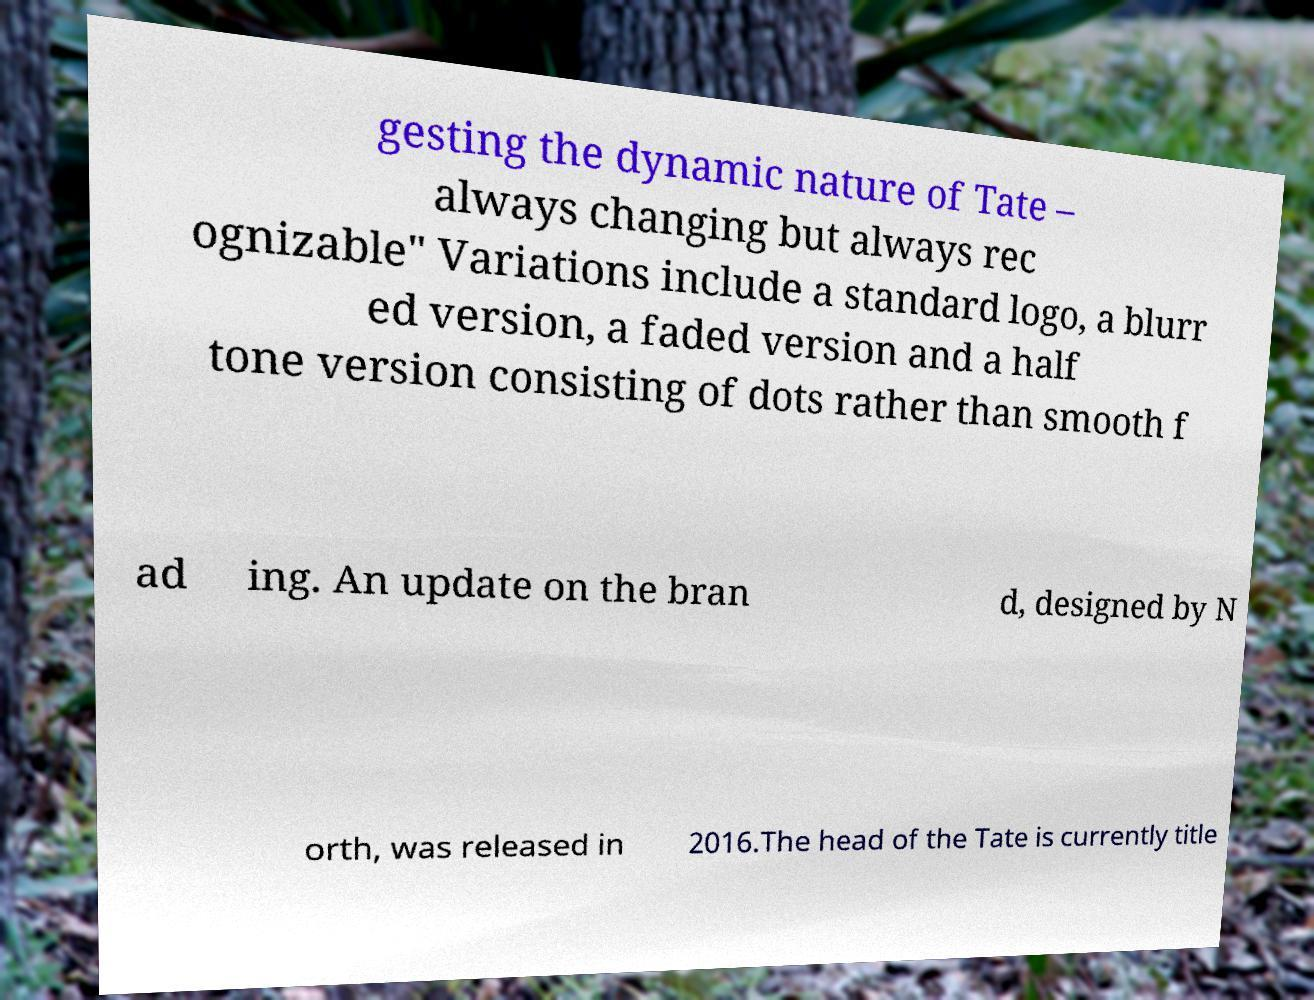Please identify and transcribe the text found in this image. gesting the dynamic nature of Tate – always changing but always rec ognizable" Variations include a standard logo, a blurr ed version, a faded version and a half tone version consisting of dots rather than smooth f ad ing. An update on the bran d, designed by N orth, was released in 2016.The head of the Tate is currently title 